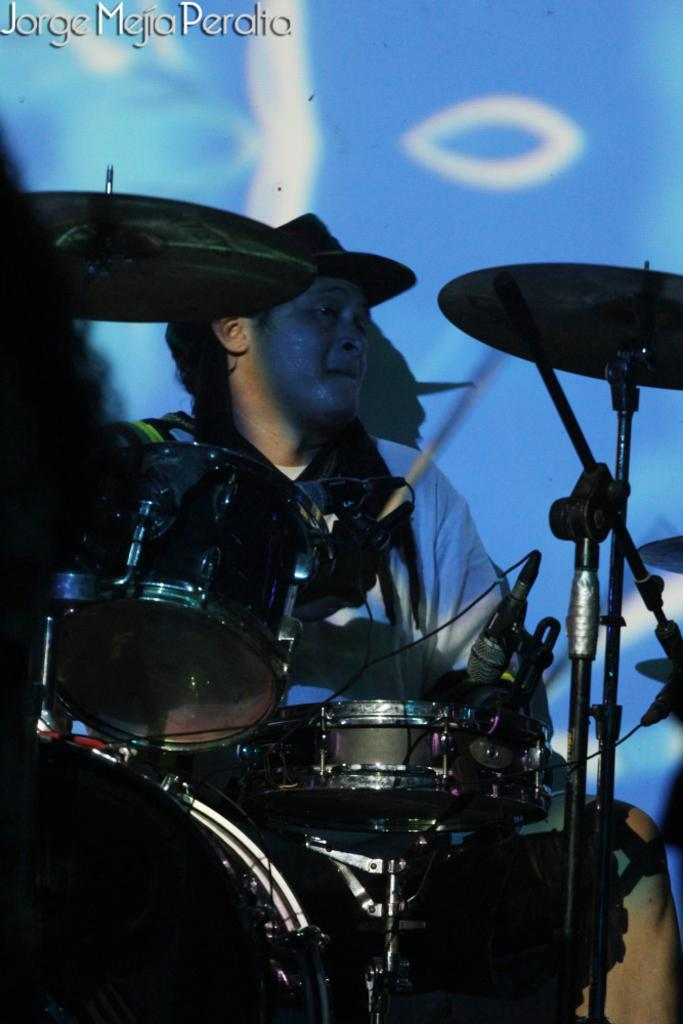What musical instruments are at the bottom of the image? There are drums at the bottom of the image. What device is present for amplifying sound in the image? There is a microphone in the image. Who is positioned near the drums in the image? A person is sitting behind the drums. What can be seen behind the person in the image? There is a banner behind the person. How many frogs are sitting on the drums in the image? There are no frogs present in the image; it features a person sitting behind the drums. What type of structure is holding the banner in the image? There is no visible structure holding the banner in the image; it is simply hanging behind the person. 